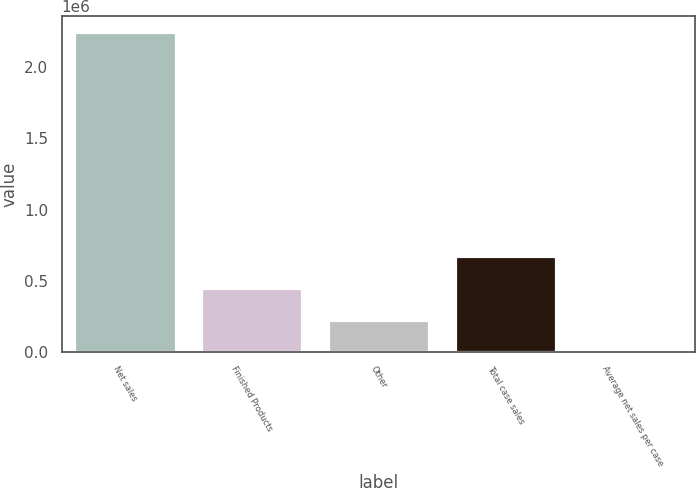<chart> <loc_0><loc_0><loc_500><loc_500><bar_chart><fcel>Net sales<fcel>Finished Products<fcel>Other<fcel>Total case sales<fcel>Average net sales per case<nl><fcel>2.24643e+06<fcel>449294<fcel>224652<fcel>673936<fcel>10.15<nl></chart> 